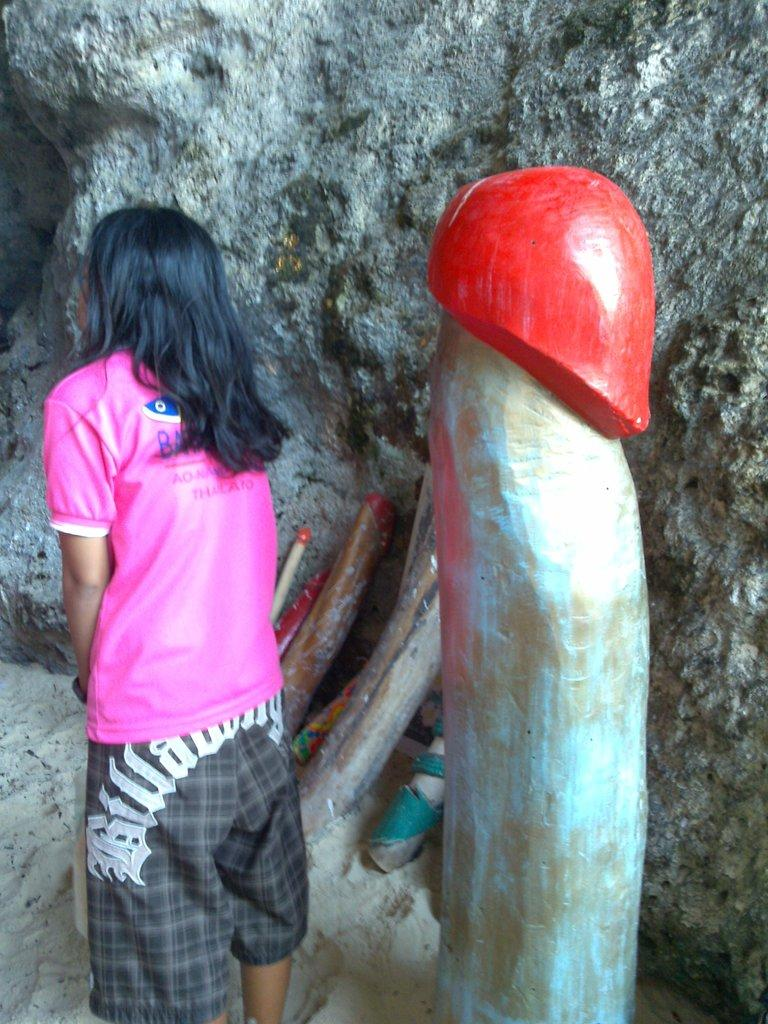Who is the main subject in the image? There is a woman standing in the front of the image. What object can be seen on the right side of the image? There is a wooden log on the right side of the image. What is visible in the background of the image? There is a wall in the background of the image. What type of lace can be seen on the woman's clothing in the image? There is no lace visible on the woman's clothing in the image. What error is present in the image? There is no error present in the image; it appears to be a clear and accurate representation of the scene. 